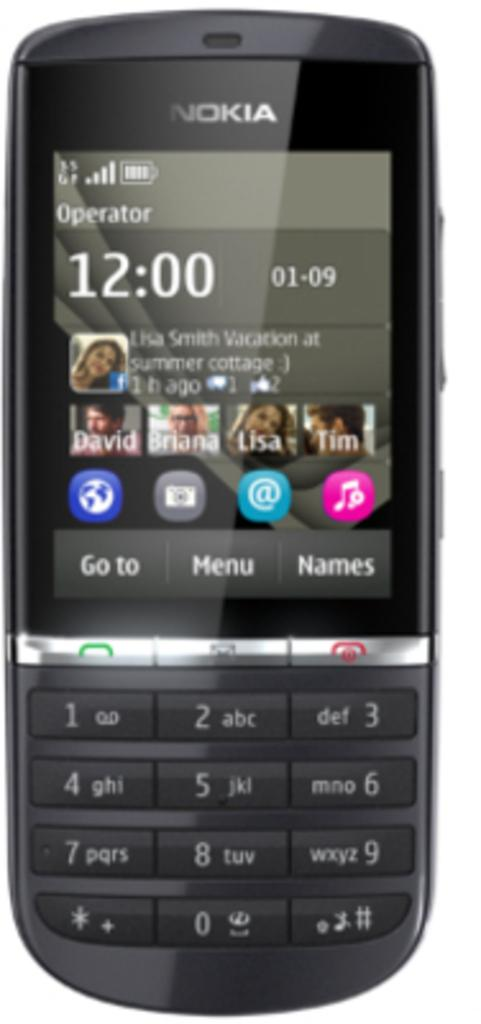<image>
Present a compact description of the photo's key features. A small Nokia phone says Operator on the screen and shows the time 12:00. 